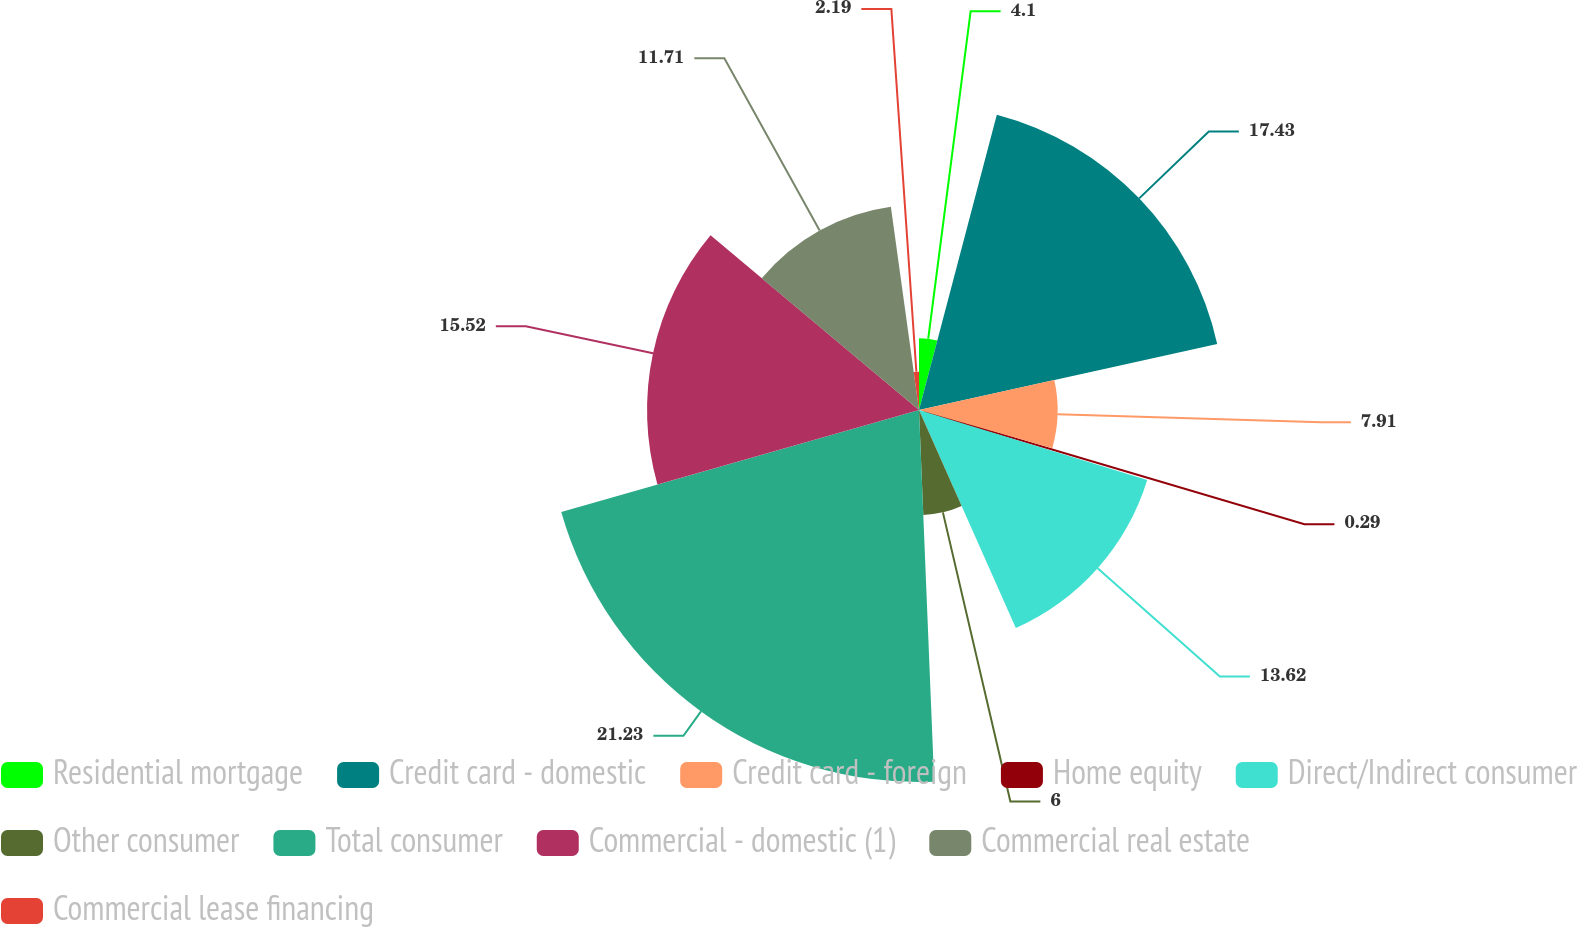Convert chart. <chart><loc_0><loc_0><loc_500><loc_500><pie_chart><fcel>Residential mortgage<fcel>Credit card - domestic<fcel>Credit card - foreign<fcel>Home equity<fcel>Direct/Indirect consumer<fcel>Other consumer<fcel>Total consumer<fcel>Commercial - domestic (1)<fcel>Commercial real estate<fcel>Commercial lease financing<nl><fcel>4.1%<fcel>17.43%<fcel>7.91%<fcel>0.29%<fcel>13.62%<fcel>6.0%<fcel>21.23%<fcel>15.52%<fcel>11.71%<fcel>2.19%<nl></chart> 